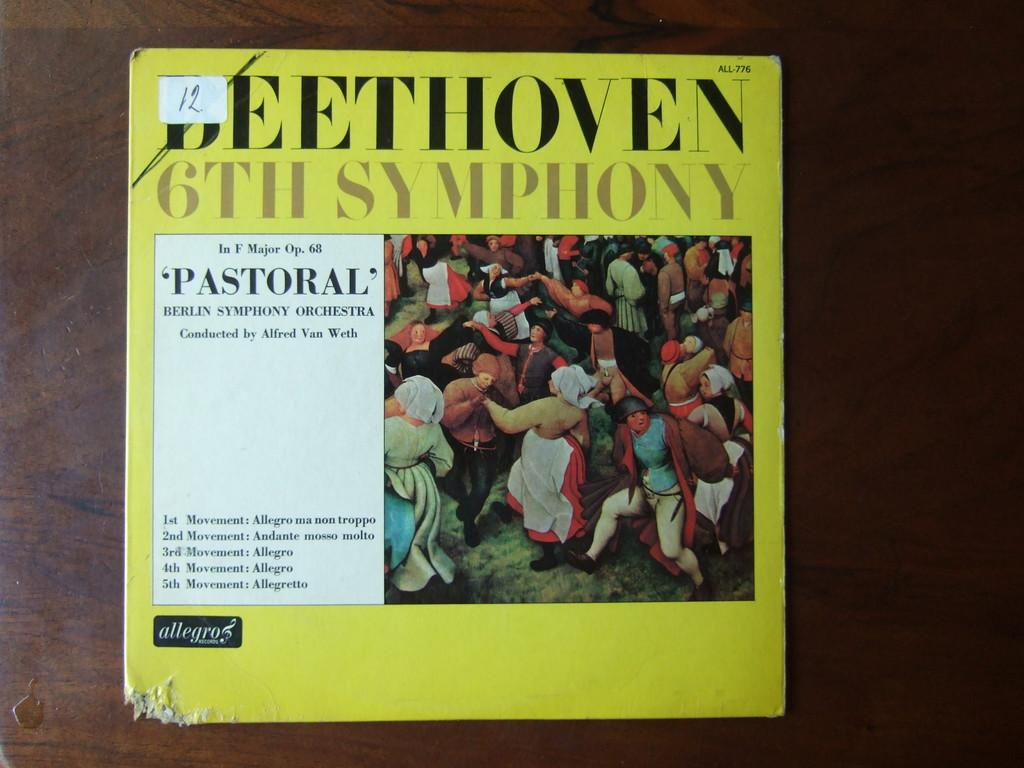<image>
Relay a brief, clear account of the picture shown. A sticker with the number 12 on it is on the cover of a book. 